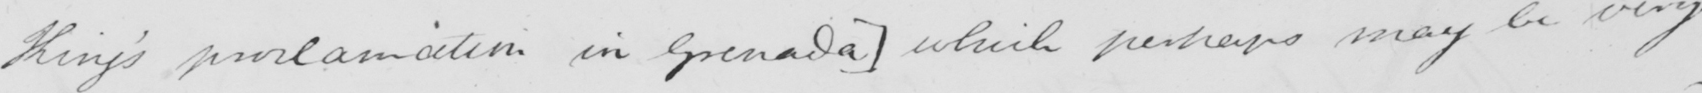What text is written in this handwritten line? King ' s proclamation in Granada ]  which perhaps may be very 